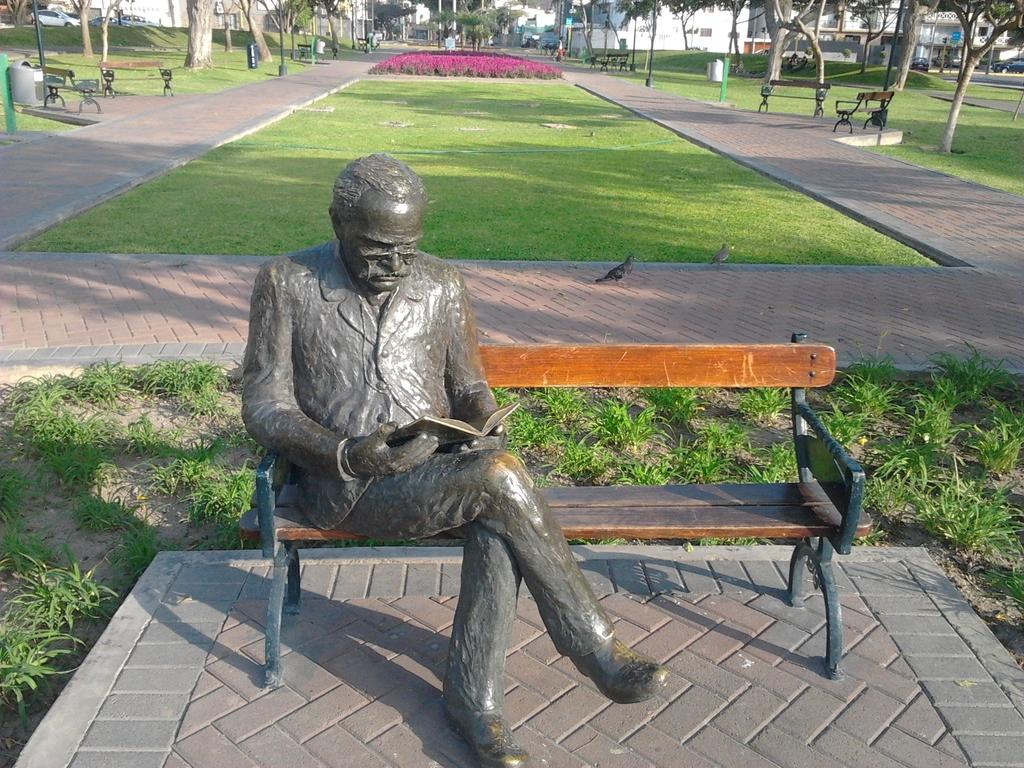What is the main subject of the image? There is a statue of a person in the image. What is the person holding in their hand? The person is holding a book in their hand. Where is the person sitting? The person is sitting on a bench. What can be seen in the background of the image? There is grass, trees, buildings, and bins in the background of the image. What type of amusement can be seen in the image? There is no amusement present in the image; it features a statue of a person sitting on a bench holding a book. Can you tell me what time it is according to the clock in the image? There is no clock present in the image. 